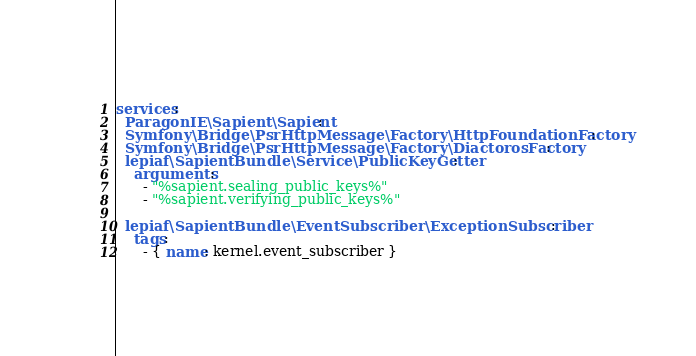Convert code to text. <code><loc_0><loc_0><loc_500><loc_500><_YAML_>services:
  ParagonIE\Sapient\Sapient:
  Symfony\Bridge\PsrHttpMessage\Factory\HttpFoundationFactory:
  Symfony\Bridge\PsrHttpMessage\Factory\DiactorosFactory:
  lepiaf\SapientBundle\Service\PublicKeyGetter:
    arguments:
      - "%sapient.sealing_public_keys%"
      - "%sapient.verifying_public_keys%"

  lepiaf\SapientBundle\EventSubscriber\ExceptionSubscriber:
    tags:
      - { name: kernel.event_subscriber }
</code> 